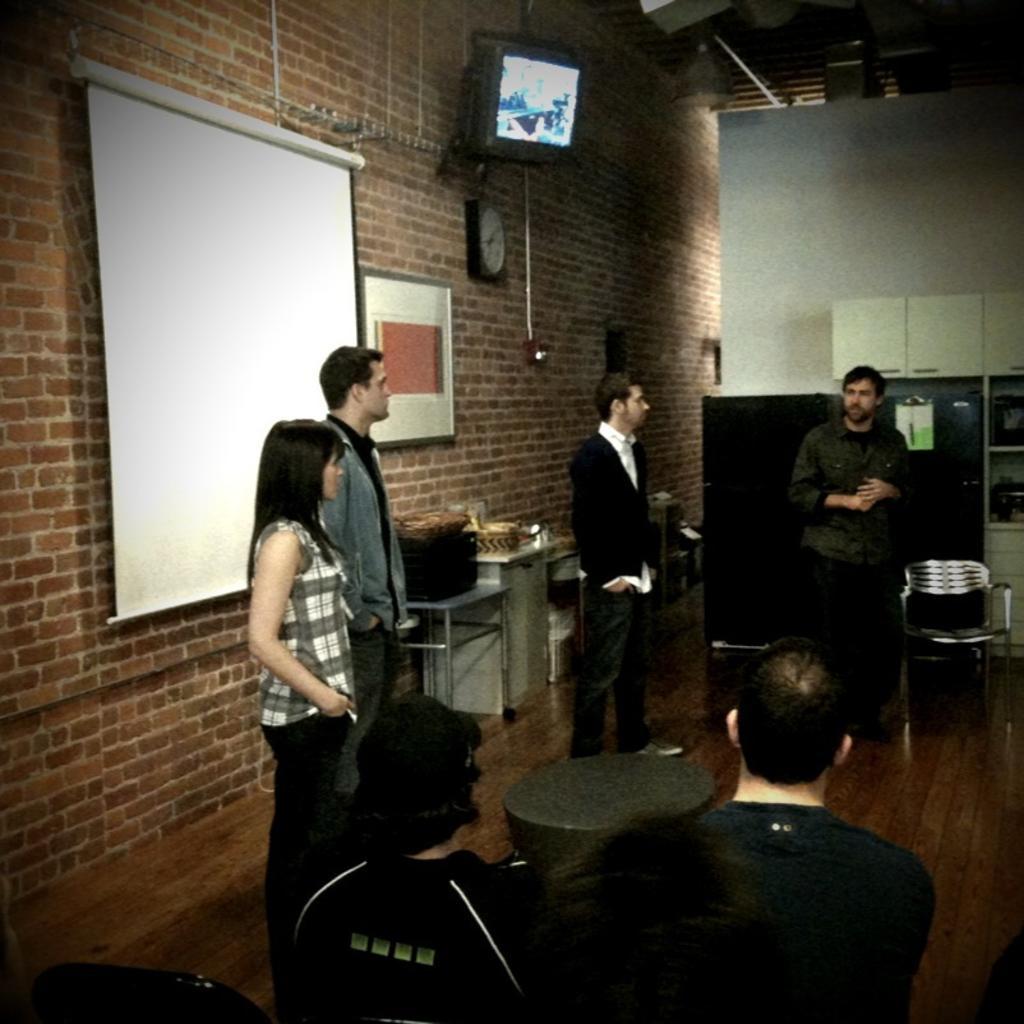In one or two sentences, can you explain what this image depicts? Here we can see that some persons are sitting and some are standing, and here is the table, and at back here is the wall and television, and projector and many objects on it. 